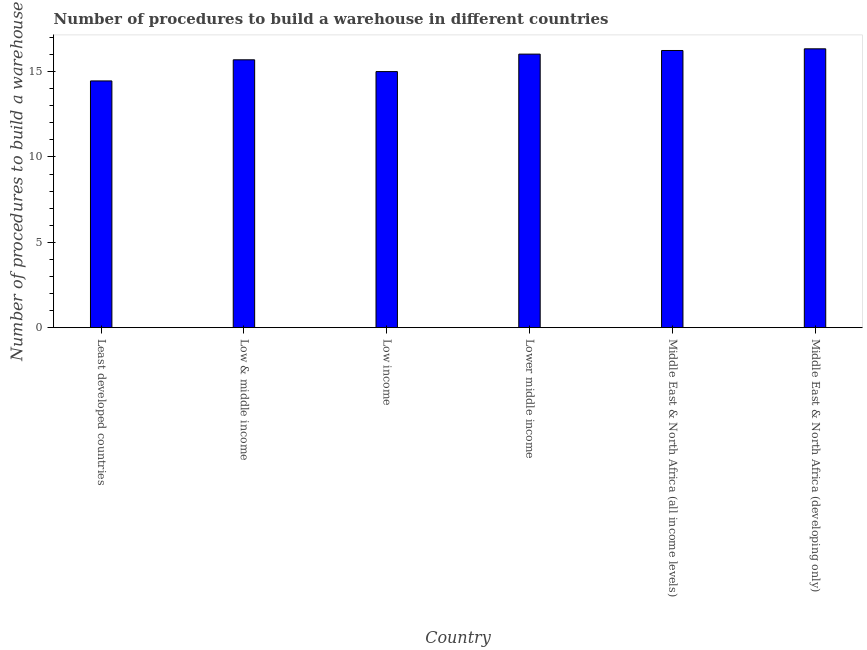Does the graph contain grids?
Give a very brief answer. No. What is the title of the graph?
Make the answer very short. Number of procedures to build a warehouse in different countries. What is the label or title of the X-axis?
Your response must be concise. Country. What is the label or title of the Y-axis?
Give a very brief answer. Number of procedures to build a warehouse. Across all countries, what is the maximum number of procedures to build a warehouse?
Give a very brief answer. 16.33. Across all countries, what is the minimum number of procedures to build a warehouse?
Your answer should be compact. 14.45. In which country was the number of procedures to build a warehouse maximum?
Your answer should be very brief. Middle East & North Africa (developing only). In which country was the number of procedures to build a warehouse minimum?
Ensure brevity in your answer.  Least developed countries. What is the sum of the number of procedures to build a warehouse?
Offer a terse response. 93.73. What is the difference between the number of procedures to build a warehouse in Low income and Middle East & North Africa (all income levels)?
Ensure brevity in your answer.  -1.24. What is the average number of procedures to build a warehouse per country?
Your response must be concise. 15.62. What is the median number of procedures to build a warehouse?
Your response must be concise. 15.86. In how many countries, is the number of procedures to build a warehouse greater than 8 ?
Keep it short and to the point. 6. Is the difference between the number of procedures to build a warehouse in Low income and Lower middle income greater than the difference between any two countries?
Offer a very short reply. No. What is the difference between the highest and the second highest number of procedures to build a warehouse?
Offer a very short reply. 0.1. What is the difference between the highest and the lowest number of procedures to build a warehouse?
Offer a terse response. 1.88. In how many countries, is the number of procedures to build a warehouse greater than the average number of procedures to build a warehouse taken over all countries?
Keep it short and to the point. 4. Are all the bars in the graph horizontal?
Give a very brief answer. No. How many countries are there in the graph?
Provide a short and direct response. 6. Are the values on the major ticks of Y-axis written in scientific E-notation?
Ensure brevity in your answer.  No. What is the Number of procedures to build a warehouse in Least developed countries?
Make the answer very short. 14.45. What is the Number of procedures to build a warehouse in Low & middle income?
Offer a very short reply. 15.69. What is the Number of procedures to build a warehouse of Low income?
Offer a very short reply. 15. What is the Number of procedures to build a warehouse of Lower middle income?
Your answer should be compact. 16.02. What is the Number of procedures to build a warehouse of Middle East & North Africa (all income levels)?
Your answer should be compact. 16.24. What is the Number of procedures to build a warehouse in Middle East & North Africa (developing only)?
Offer a very short reply. 16.33. What is the difference between the Number of procedures to build a warehouse in Least developed countries and Low & middle income?
Offer a very short reply. -1.24. What is the difference between the Number of procedures to build a warehouse in Least developed countries and Low income?
Offer a very short reply. -0.55. What is the difference between the Number of procedures to build a warehouse in Least developed countries and Lower middle income?
Your answer should be very brief. -1.57. What is the difference between the Number of procedures to build a warehouse in Least developed countries and Middle East & North Africa (all income levels)?
Ensure brevity in your answer.  -1.78. What is the difference between the Number of procedures to build a warehouse in Least developed countries and Middle East & North Africa (developing only)?
Your answer should be compact. -1.88. What is the difference between the Number of procedures to build a warehouse in Low & middle income and Low income?
Make the answer very short. 0.69. What is the difference between the Number of procedures to build a warehouse in Low & middle income and Lower middle income?
Give a very brief answer. -0.33. What is the difference between the Number of procedures to build a warehouse in Low & middle income and Middle East & North Africa (all income levels)?
Your response must be concise. -0.55. What is the difference between the Number of procedures to build a warehouse in Low & middle income and Middle East & North Africa (developing only)?
Your answer should be compact. -0.64. What is the difference between the Number of procedures to build a warehouse in Low income and Lower middle income?
Make the answer very short. -1.02. What is the difference between the Number of procedures to build a warehouse in Low income and Middle East & North Africa (all income levels)?
Provide a short and direct response. -1.24. What is the difference between the Number of procedures to build a warehouse in Low income and Middle East & North Africa (developing only)?
Your response must be concise. -1.33. What is the difference between the Number of procedures to build a warehouse in Lower middle income and Middle East & North Africa (all income levels)?
Your response must be concise. -0.21. What is the difference between the Number of procedures to build a warehouse in Lower middle income and Middle East & North Africa (developing only)?
Your response must be concise. -0.31. What is the difference between the Number of procedures to build a warehouse in Middle East & North Africa (all income levels) and Middle East & North Africa (developing only)?
Provide a short and direct response. -0.1. What is the ratio of the Number of procedures to build a warehouse in Least developed countries to that in Low & middle income?
Ensure brevity in your answer.  0.92. What is the ratio of the Number of procedures to build a warehouse in Least developed countries to that in Lower middle income?
Your answer should be compact. 0.9. What is the ratio of the Number of procedures to build a warehouse in Least developed countries to that in Middle East & North Africa (all income levels)?
Your answer should be very brief. 0.89. What is the ratio of the Number of procedures to build a warehouse in Least developed countries to that in Middle East & North Africa (developing only)?
Ensure brevity in your answer.  0.89. What is the ratio of the Number of procedures to build a warehouse in Low & middle income to that in Low income?
Offer a terse response. 1.05. What is the ratio of the Number of procedures to build a warehouse in Low & middle income to that in Lower middle income?
Your answer should be very brief. 0.98. What is the ratio of the Number of procedures to build a warehouse in Low & middle income to that in Middle East & North Africa (developing only)?
Your answer should be compact. 0.96. What is the ratio of the Number of procedures to build a warehouse in Low income to that in Lower middle income?
Your response must be concise. 0.94. What is the ratio of the Number of procedures to build a warehouse in Low income to that in Middle East & North Africa (all income levels)?
Offer a very short reply. 0.92. What is the ratio of the Number of procedures to build a warehouse in Low income to that in Middle East & North Africa (developing only)?
Make the answer very short. 0.92. What is the ratio of the Number of procedures to build a warehouse in Middle East & North Africa (all income levels) to that in Middle East & North Africa (developing only)?
Offer a very short reply. 0.99. 